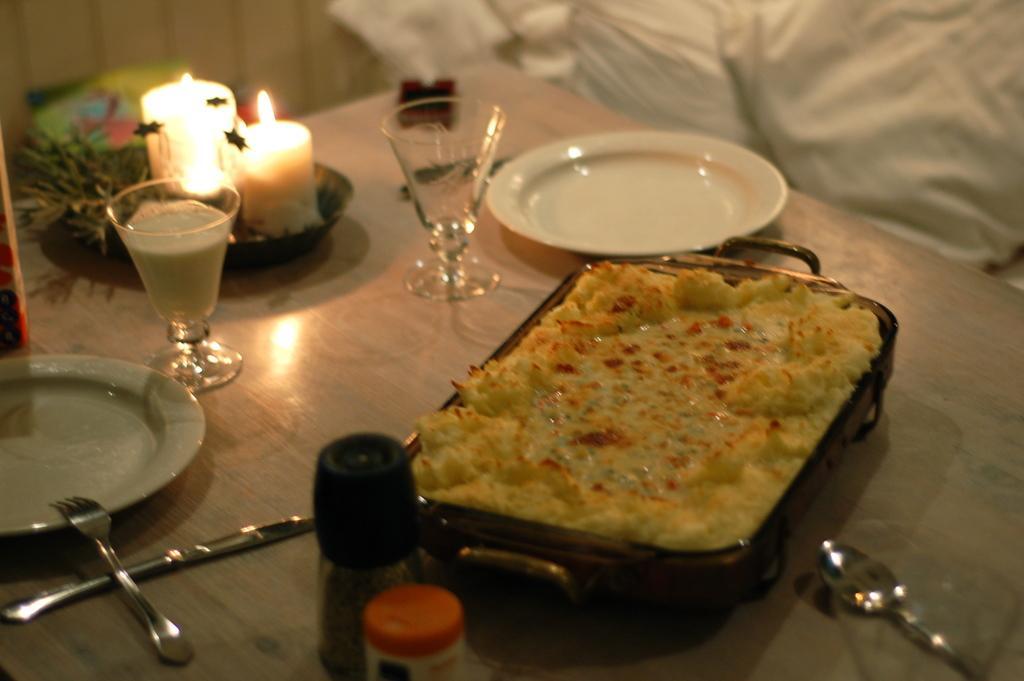Describe this image in one or two sentences. At the bottom of this image, there are two plates, a food item in an object, there are two candle lights, two glasses, bottles, a spoon, a fork and other objects arranged on a wooden table. In the background, there is a wall and there are white colored clothes and other objects. 